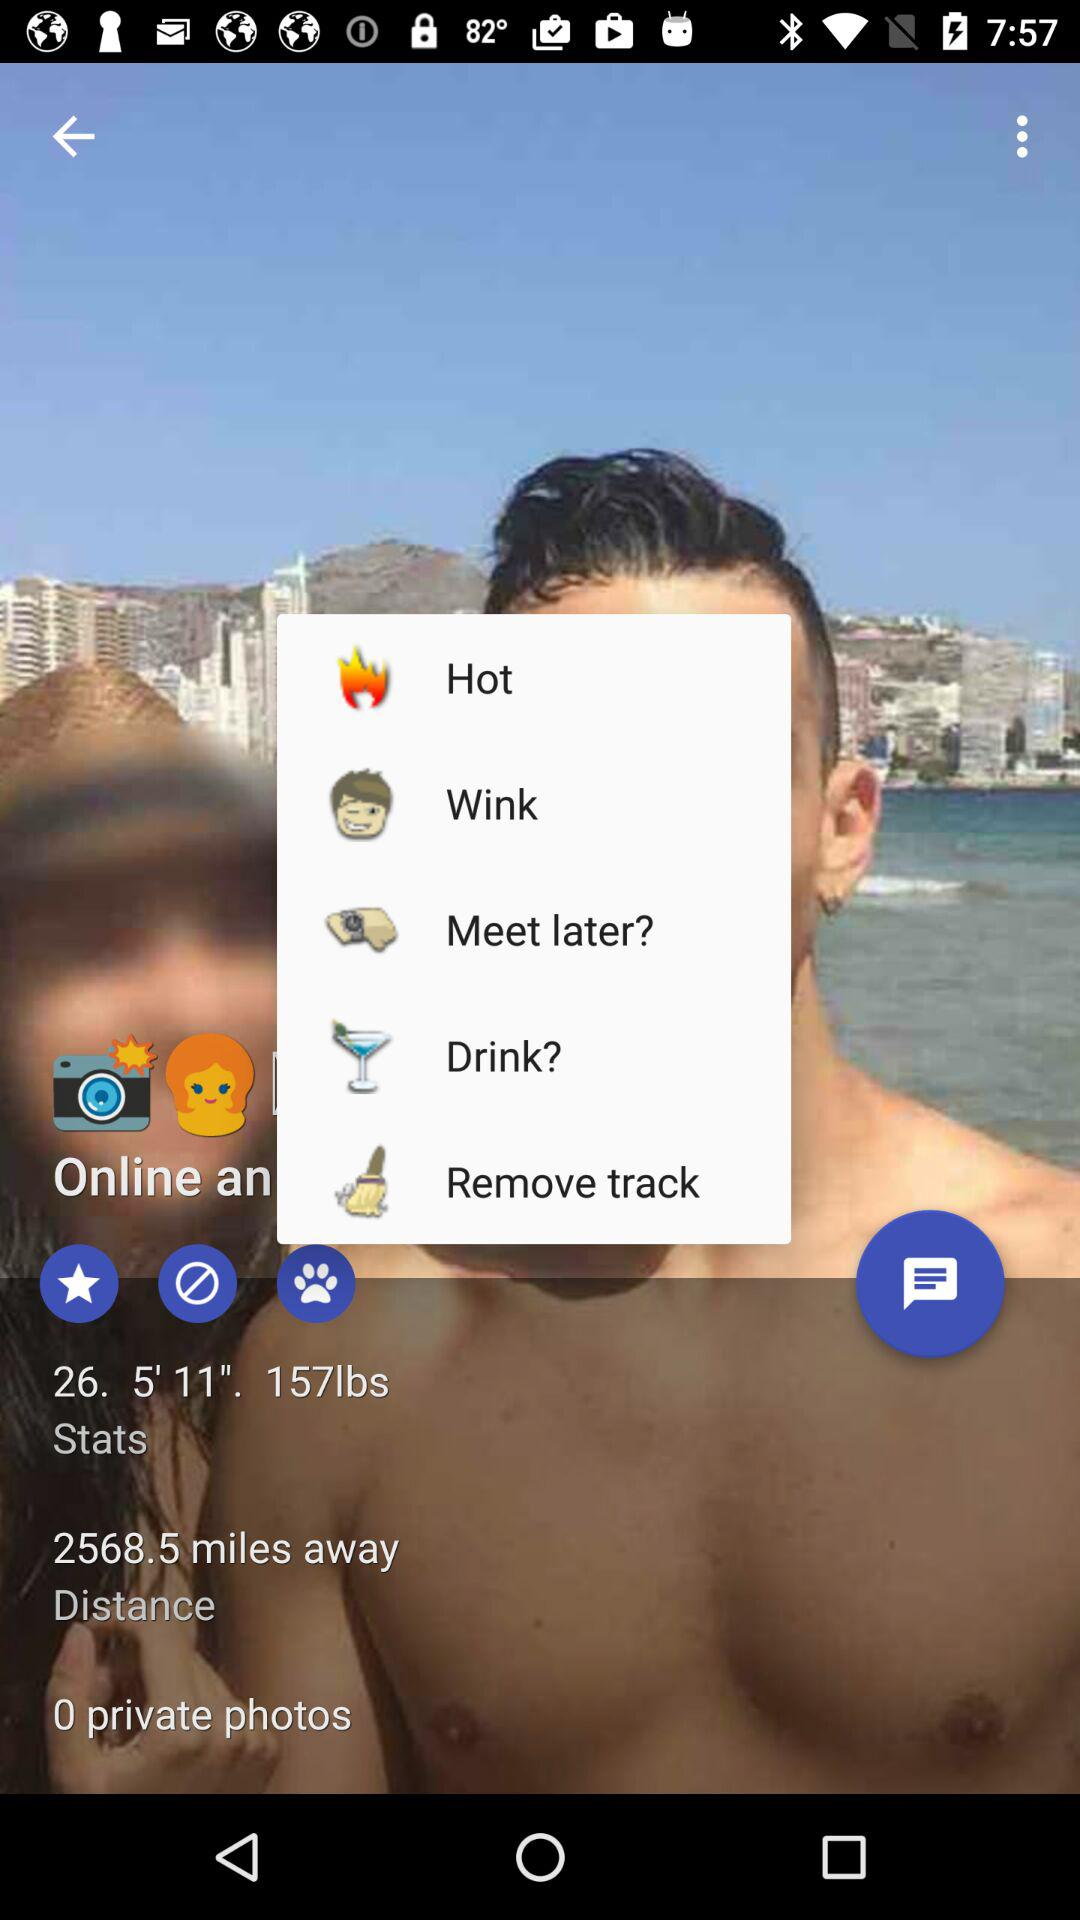How many miles away is it? It is 2568.5 miles away. 